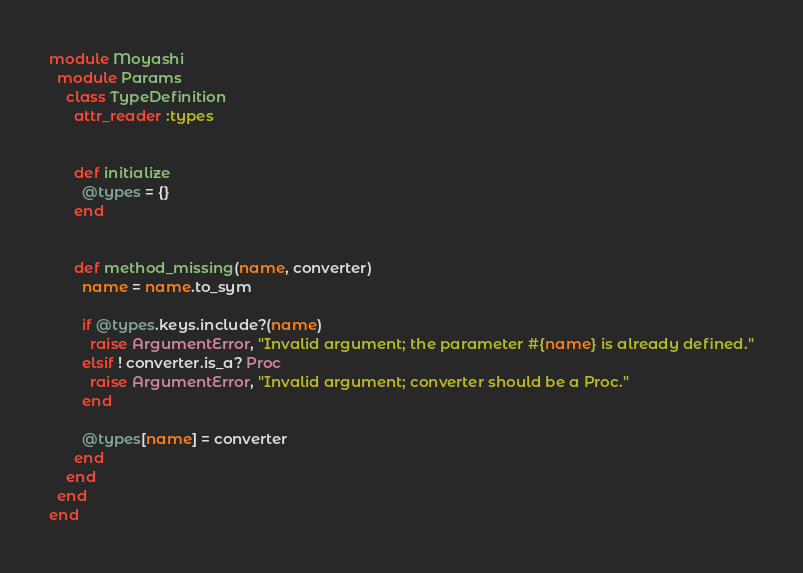<code> <loc_0><loc_0><loc_500><loc_500><_Ruby_>module Moyashi
  module Params
    class TypeDefinition
      attr_reader :types


      def initialize
        @types = {}
      end


      def method_missing(name, converter)
        name = name.to_sym

        if @types.keys.include?(name)
          raise ArgumentError, "Invalid argument; the parameter #{name} is already defined."
        elsif ! converter.is_a? Proc
          raise ArgumentError, "Invalid argument; converter should be a Proc."
        end

        @types[name] = converter
      end
    end
  end
end</code> 